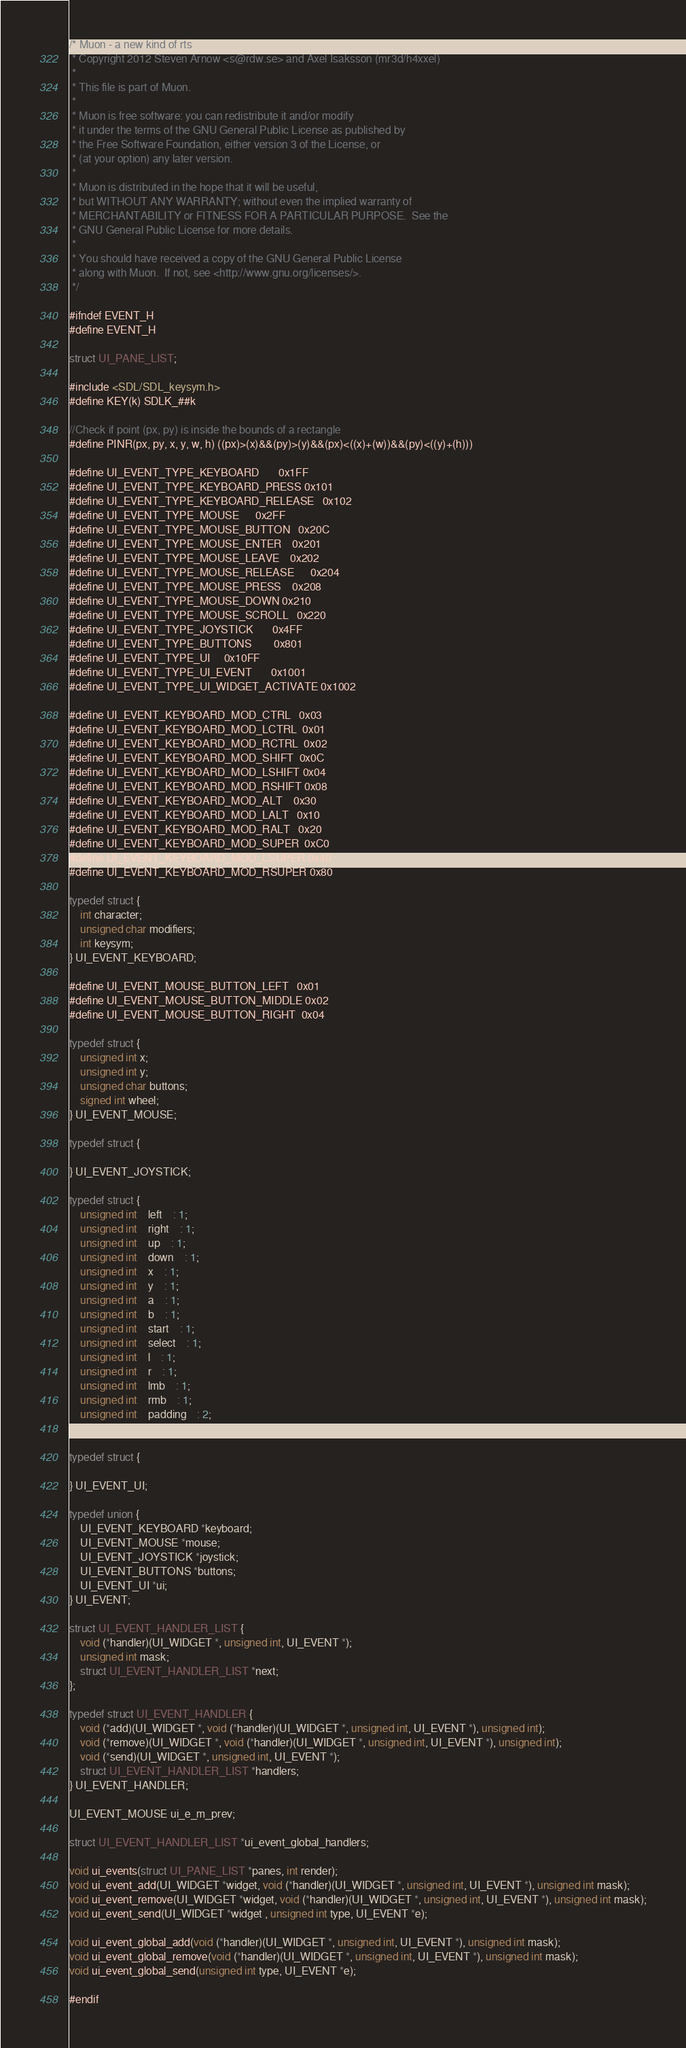Convert code to text. <code><loc_0><loc_0><loc_500><loc_500><_C_>/* Muon - a new kind of rts
 * Copyright 2012 Steven Arnow <s@rdw.se> and Axel Isaksson (mr3d/h4xxel)
 * 
 * This file is part of Muon.
 * 
 * Muon is free software: you can redistribute it and/or modify
 * it under the terms of the GNU General Public License as published by
 * the Free Software Foundation, either version 3 of the License, or
 * (at your option) any later version.
 * 
 * Muon is distributed in the hope that it will be useful,
 * but WITHOUT ANY WARRANTY; without even the implied warranty of
 * MERCHANTABILITY or FITNESS FOR A PARTICULAR PURPOSE.  See the
 * GNU General Public License for more details.
 * 
 * You should have received a copy of the GNU General Public License
 * along with Muon.  If not, see <http://www.gnu.org/licenses/>.
 */

#ifndef EVENT_H
#define EVENT_H

struct UI_PANE_LIST;

#include <SDL/SDL_keysym.h>
#define KEY(k) SDLK_##k

//Check if point (px, py) is inside the bounds of a rectangle
#define PINR(px, py, x, y, w, h) ((px)>(x)&&(py)>(y)&&(px)<((x)+(w))&&(py)<((y)+(h)))

#define UI_EVENT_TYPE_KEYBOARD		0x1FF
#define UI_EVENT_TYPE_KEYBOARD_PRESS	0x101
#define UI_EVENT_TYPE_KEYBOARD_RELEASE	0x102
#define UI_EVENT_TYPE_MOUSE		0x2FF
#define UI_EVENT_TYPE_MOUSE_BUTTON	0x20C
#define UI_EVENT_TYPE_MOUSE_ENTER	0x201
#define UI_EVENT_TYPE_MOUSE_LEAVE	0x202
#define UI_EVENT_TYPE_MOUSE_RELEASE		0x204
#define UI_EVENT_TYPE_MOUSE_PRESS	0x208
#define UI_EVENT_TYPE_MOUSE_DOWN	0x210
#define UI_EVENT_TYPE_MOUSE_SCROLL	0x220
#define UI_EVENT_TYPE_JOYSTICK		0x4FF
#define UI_EVENT_TYPE_BUTTONS		0x801
#define UI_EVENT_TYPE_UI		0x10FF
#define UI_EVENT_TYPE_UI_EVENT		0x1001
#define UI_EVENT_TYPE_UI_WIDGET_ACTIVATE	0x1002

#define UI_EVENT_KEYBOARD_MOD_CTRL	0x03
#define UI_EVENT_KEYBOARD_MOD_LCTRL	0x01
#define UI_EVENT_KEYBOARD_MOD_RCTRL	0x02
#define UI_EVENT_KEYBOARD_MOD_SHIFT	0x0C
#define UI_EVENT_KEYBOARD_MOD_LSHIFT	0x04
#define UI_EVENT_KEYBOARD_MOD_RSHIFT	0x08
#define UI_EVENT_KEYBOARD_MOD_ALT	0x30
#define UI_EVENT_KEYBOARD_MOD_LALT	0x10
#define UI_EVENT_KEYBOARD_MOD_RALT	0x20
#define UI_EVENT_KEYBOARD_MOD_SUPER	0xC0
#define UI_EVENT_KEYBOARD_MOD_LSUPER	0x40
#define UI_EVENT_KEYBOARD_MOD_RSUPER	0x80

typedef struct {
	int character;
	unsigned char modifiers;
	int keysym;
} UI_EVENT_KEYBOARD;

#define UI_EVENT_MOUSE_BUTTON_LEFT	0x01
#define UI_EVENT_MOUSE_BUTTON_MIDDLE	0x02
#define UI_EVENT_MOUSE_BUTTON_RIGHT	0x04

typedef struct {
	unsigned int x;
	unsigned int y;
	unsigned char buttons;
	signed int wheel;
} UI_EVENT_MOUSE;

typedef struct {
	
} UI_EVENT_JOYSTICK;

typedef struct {
	unsigned int	left	: 1;
	unsigned int	right	: 1;
	unsigned int	up	: 1;
	unsigned int	down	: 1;
	unsigned int	x	: 1;
	unsigned int	y	: 1;
	unsigned int	a	: 1;
	unsigned int	b	: 1;
	unsigned int	start	: 1;
	unsigned int	select	: 1;
	unsigned int	l	: 1;
	unsigned int	r	: 1;
	unsigned int	lmb	: 1;
	unsigned int	rmb	: 1;
	unsigned int	padding	: 2;
} UI_EVENT_BUTTONS;

typedef struct {
	
} UI_EVENT_UI;

typedef union {
	UI_EVENT_KEYBOARD *keyboard;
	UI_EVENT_MOUSE *mouse;
	UI_EVENT_JOYSTICK *joystick;
	UI_EVENT_BUTTONS *buttons;
	UI_EVENT_UI *ui;
} UI_EVENT;

struct UI_EVENT_HANDLER_LIST {
	void (*handler)(UI_WIDGET *, unsigned int, UI_EVENT *);
	unsigned int mask;
	struct UI_EVENT_HANDLER_LIST *next;
};

typedef struct UI_EVENT_HANDLER {
	void (*add)(UI_WIDGET *, void (*handler)(UI_WIDGET *, unsigned int, UI_EVENT *), unsigned int);
	void (*remove)(UI_WIDGET *, void (*handler)(UI_WIDGET *, unsigned int, UI_EVENT *), unsigned int);
	void (*send)(UI_WIDGET *, unsigned int, UI_EVENT *);
	struct UI_EVENT_HANDLER_LIST *handlers;
} UI_EVENT_HANDLER;

UI_EVENT_MOUSE ui_e_m_prev;

struct UI_EVENT_HANDLER_LIST *ui_event_global_handlers;

void ui_events(struct UI_PANE_LIST *panes, int render);
void ui_event_add(UI_WIDGET *widget, void (*handler)(UI_WIDGET *, unsigned int, UI_EVENT *), unsigned int mask);
void ui_event_remove(UI_WIDGET *widget, void (*handler)(UI_WIDGET *, unsigned int, UI_EVENT *), unsigned int mask);
void ui_event_send(UI_WIDGET *widget , unsigned int type, UI_EVENT *e);

void ui_event_global_add(void (*handler)(UI_WIDGET *, unsigned int, UI_EVENT *), unsigned int mask);
void ui_event_global_remove(void (*handler)(UI_WIDGET *, unsigned int, UI_EVENT *), unsigned int mask);
void ui_event_global_send(unsigned int type, UI_EVENT *e);

#endif
</code> 